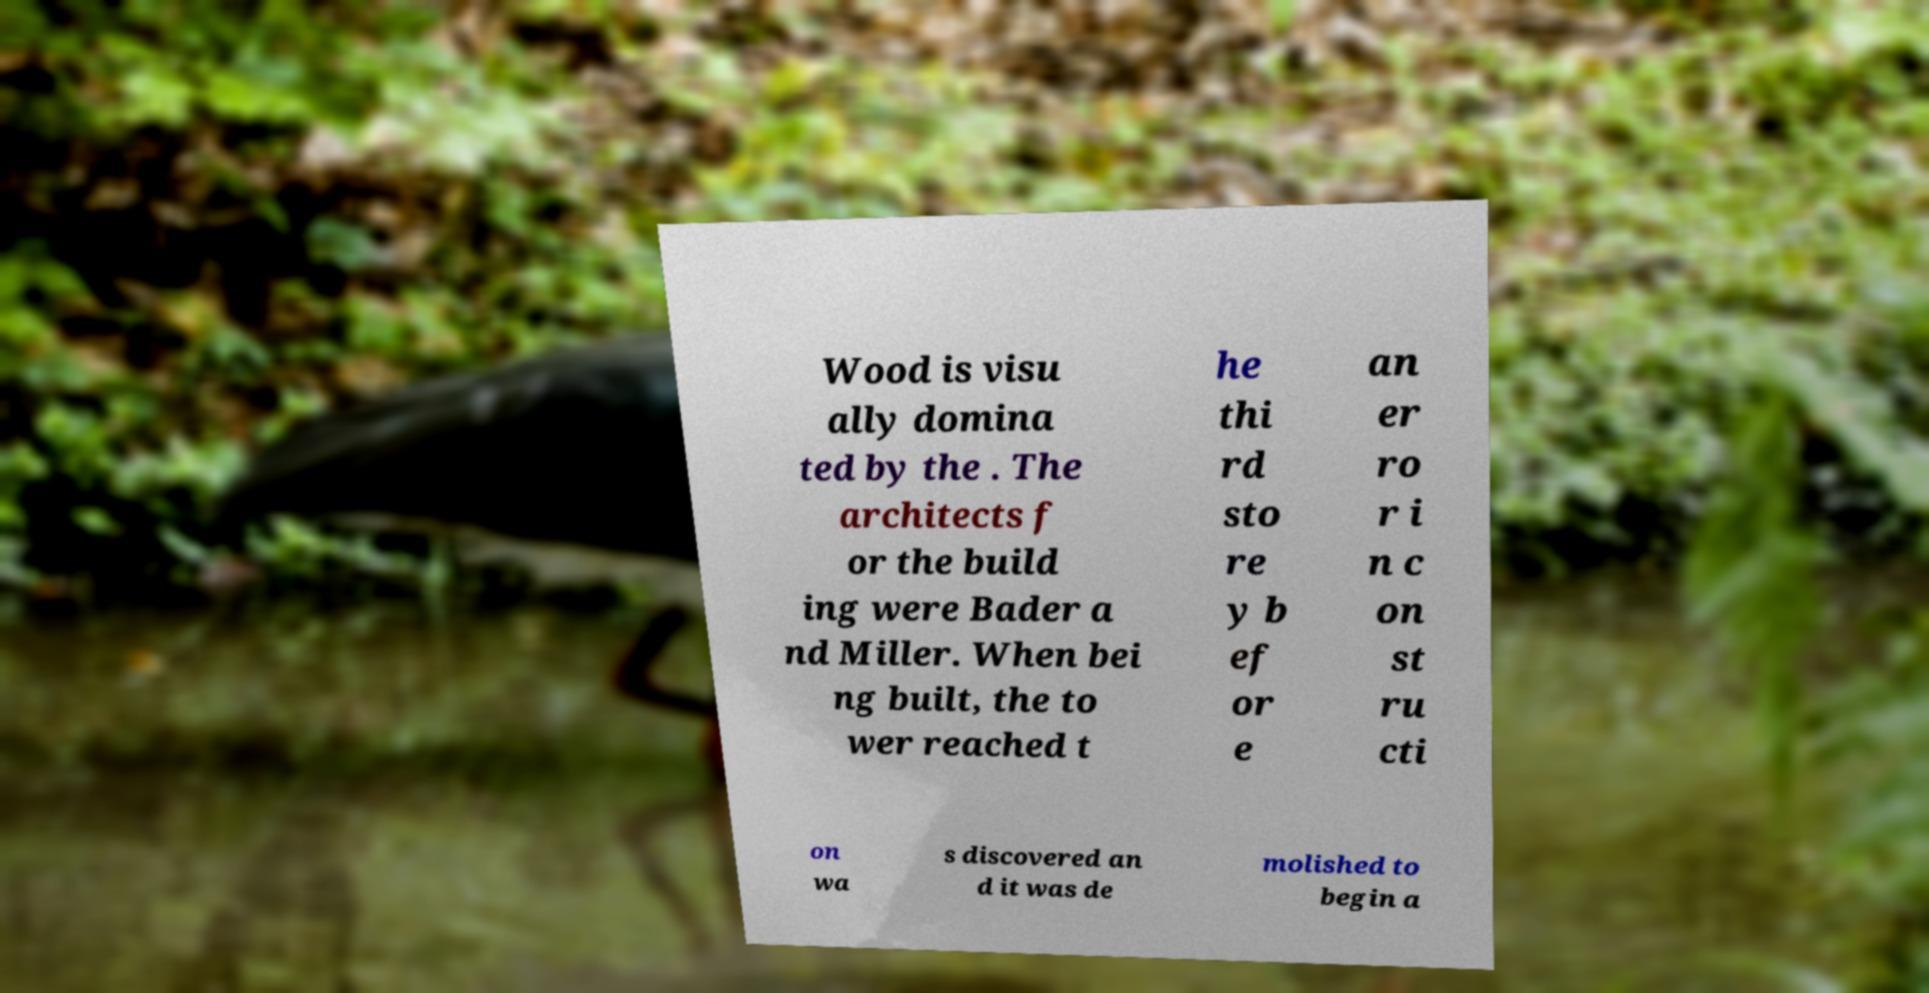Can you accurately transcribe the text from the provided image for me? Wood is visu ally domina ted by the . The architects f or the build ing were Bader a nd Miller. When bei ng built, the to wer reached t he thi rd sto re y b ef or e an er ro r i n c on st ru cti on wa s discovered an d it was de molished to begin a 